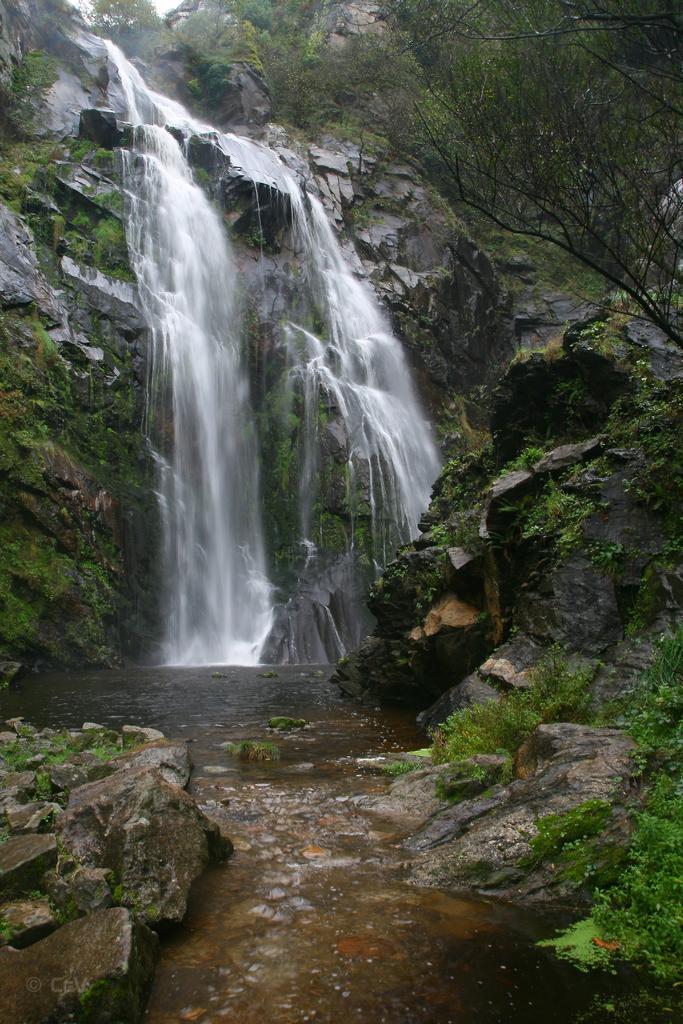Could you give a brief overview of what you see in this image? In this image there are rocks mountains. In the center there is a waterfall on the rocks. There are plants and algae on the rocks. At the top there is the sky. At the bottom there is water flowing. 